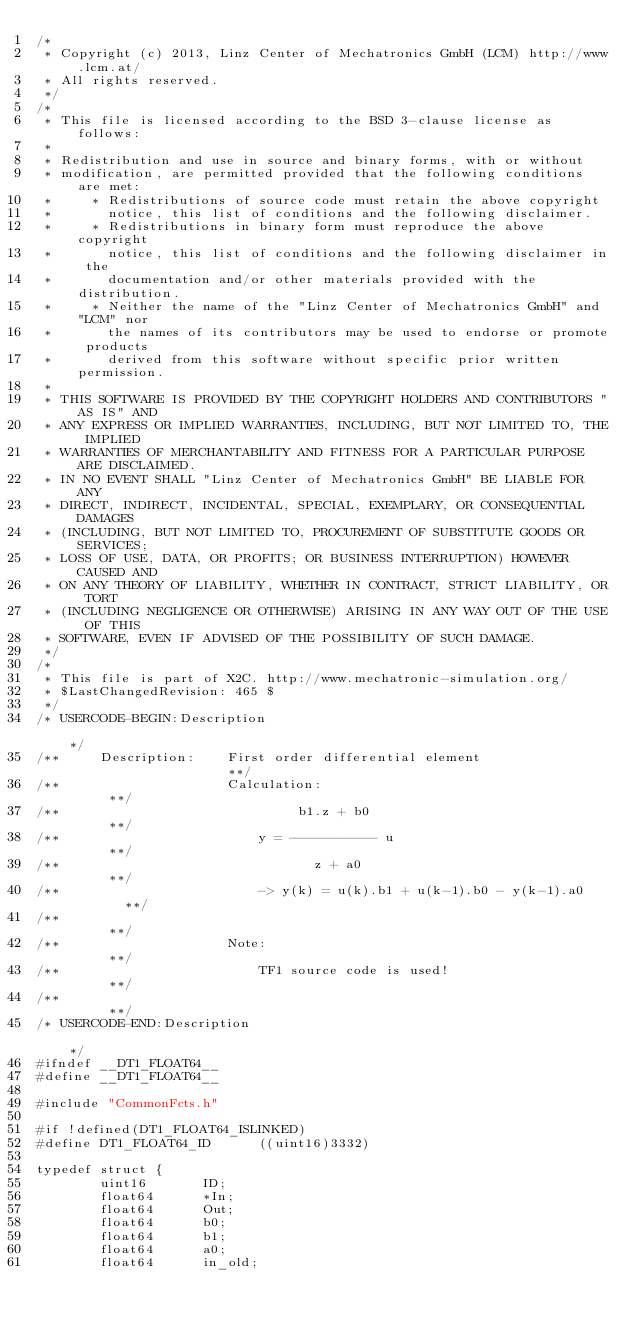Convert code to text. <code><loc_0><loc_0><loc_500><loc_500><_C_>/*
 * Copyright (c) 2013, Linz Center of Mechatronics GmbH (LCM) http://www.lcm.at/
 * All rights reserved.
 */
/*
 * This file is licensed according to the BSD 3-clause license as follows:
 * 
 * Redistribution and use in source and binary forms, with or without
 * modification, are permitted provided that the following conditions are met:
 *     * Redistributions of source code must retain the above copyright
 *       notice, this list of conditions and the following disclaimer.
 *     * Redistributions in binary form must reproduce the above copyright
 *       notice, this list of conditions and the following disclaimer in the
 *       documentation and/or other materials provided with the distribution.
 *     * Neither the name of the "Linz Center of Mechatronics GmbH" and "LCM" nor
 *       the names of its contributors may be used to endorse or promote products
 *       derived from this software without specific prior written permission.
 * 
 * THIS SOFTWARE IS PROVIDED BY THE COPYRIGHT HOLDERS AND CONTRIBUTORS "AS IS" AND
 * ANY EXPRESS OR IMPLIED WARRANTIES, INCLUDING, BUT NOT LIMITED TO, THE IMPLIED
 * WARRANTIES OF MERCHANTABILITY AND FITNESS FOR A PARTICULAR PURPOSE ARE DISCLAIMED.
 * IN NO EVENT SHALL "Linz Center of Mechatronics GmbH" BE LIABLE FOR ANY
 * DIRECT, INDIRECT, INCIDENTAL, SPECIAL, EXEMPLARY, OR CONSEQUENTIAL DAMAGES
 * (INCLUDING, BUT NOT LIMITED TO, PROCUREMENT OF SUBSTITUTE GOODS OR SERVICES;
 * LOSS OF USE, DATA, OR PROFITS; OR BUSINESS INTERRUPTION) HOWEVER CAUSED AND
 * ON ANY THEORY OF LIABILITY, WHETHER IN CONTRACT, STRICT LIABILITY, OR TORT
 * (INCLUDING NEGLIGENCE OR OTHERWISE) ARISING IN ANY WAY OUT OF THE USE OF THIS
 * SOFTWARE, EVEN IF ADVISED OF THE POSSIBILITY OF SUCH DAMAGE.
 */
/*
 * This file is part of X2C. http://www.mechatronic-simulation.org/
 * $LastChangedRevision: 465 $
 */
/* USERCODE-BEGIN:Description                                                                                         */
/**     Description:    First order differential element                     **/
/**						Calculation:										 **/
/**	       						 b1.z + b0							   		 **/
/** 						y = ----------- u						   		 **/
/**          					   z + a0									 **/
/**							-> y(k) = u(k).b1 + u(k-1).b0 - y(k-1).a0        **/
/**																			 **/
/**						Note:												 **/
/**							TF1 source code is used!						 **/
/**																			 **/
/* USERCODE-END:Description                                                                                           */
#ifndef __DT1_FLOAT64__
#define __DT1_FLOAT64__

#include "CommonFcts.h"

#if !defined(DT1_FLOAT64_ISLINKED)
#define DT1_FLOAT64_ID      ((uint16)3332)

typedef struct {
        uint16       ID;
        float64      *In;
        float64      Out;
        float64      b0;
        float64      b1;
        float64      a0;
        float64      in_old;</code> 